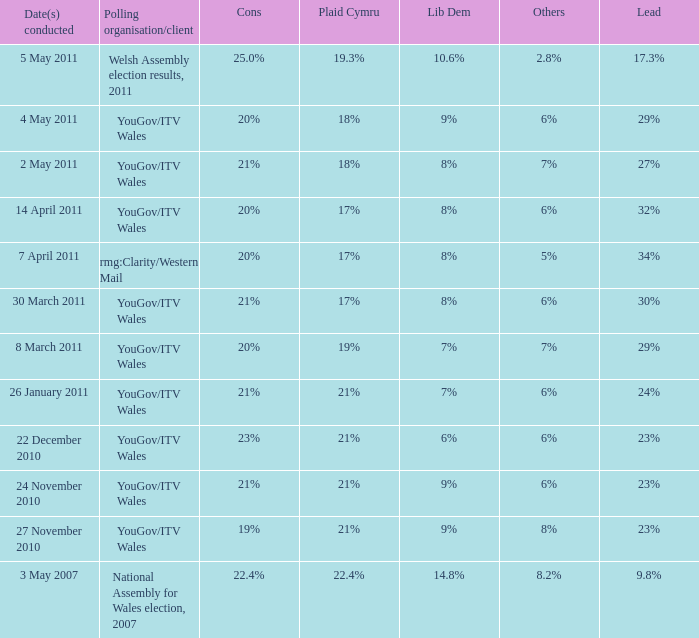Reveal the dates executed for plaid cymru at 19%. 8 March 2011. 